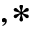<formula> <loc_0><loc_0><loc_500><loc_500>^ { , * }</formula> 